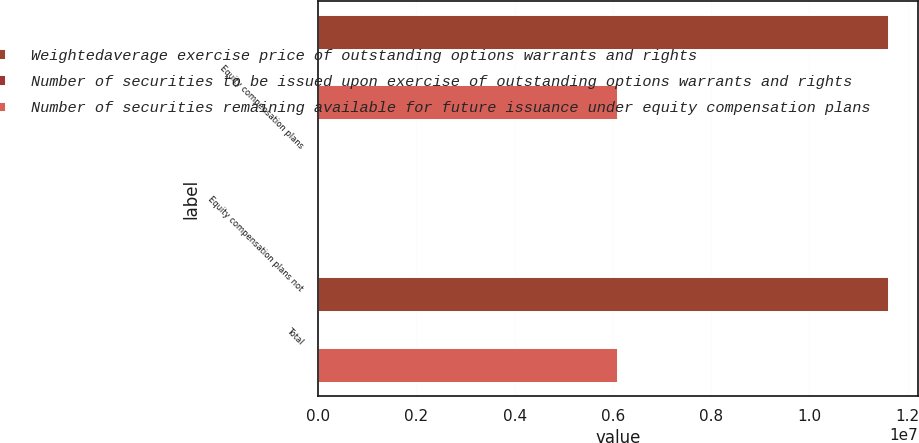<chart> <loc_0><loc_0><loc_500><loc_500><stacked_bar_chart><ecel><fcel>Equity compensation plans<fcel>Equity compensation plans not<fcel>Total<nl><fcel>Weightedaverage exercise price of outstanding options warrants and rights<fcel>1.16204e+07<fcel>0<fcel>1.16204e+07<nl><fcel>Number of securities to be issued upon exercise of outstanding options warrants and rights<fcel>35.42<fcel>0<fcel>35.42<nl><fcel>Number of securities remaining available for future issuance under equity compensation plans<fcel>6.09934e+06<fcel>0<fcel>6.09934e+06<nl></chart> 